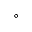Convert formula to latex. <formula><loc_0><loc_0><loc_500><loc_500>^ { \circ }</formula> 